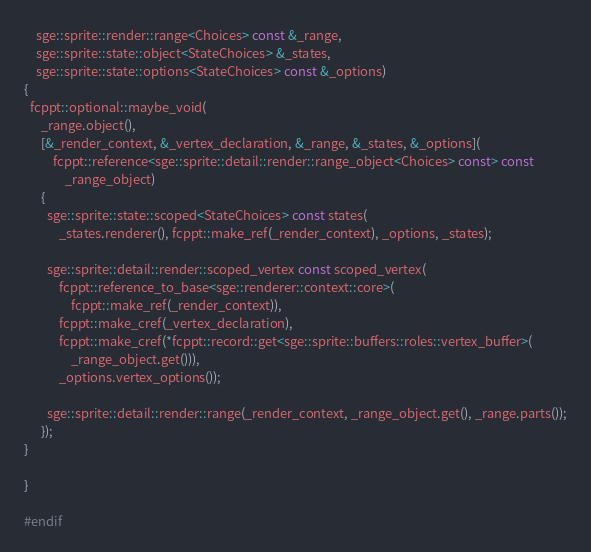<code> <loc_0><loc_0><loc_500><loc_500><_C++_>    sge::sprite::render::range<Choices> const &_range,
    sge::sprite::state::object<StateChoices> &_states,
    sge::sprite::state::options<StateChoices> const &_options)
{
  fcppt::optional::maybe_void(
      _range.object(),
      [&_render_context, &_vertex_declaration, &_range, &_states, &_options](
          fcppt::reference<sge::sprite::detail::render::range_object<Choices> const> const
              _range_object)
      {
        sge::sprite::state::scoped<StateChoices> const states(
            _states.renderer(), fcppt::make_ref(_render_context), _options, _states);

        sge::sprite::detail::render::scoped_vertex const scoped_vertex(
            fcppt::reference_to_base<sge::renderer::context::core>(
                fcppt::make_ref(_render_context)),
            fcppt::make_cref(_vertex_declaration),
            fcppt::make_cref(*fcppt::record::get<sge::sprite::buffers::roles::vertex_buffer>(
                _range_object.get())),
            _options.vertex_options());

        sge::sprite::detail::render::range(_render_context, _range_object.get(), _range.parts());
      });
}

}

#endif
</code> 